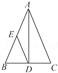Elucidate the elements visible in the diagram. The diagram depicts triangle ABC with vertices labeled as A, B, and C. From vertex A, an altitude (perpendicular segment) is drawn, intersecting side BC at point D. Additionally, point E is marked on the diagram, representing the midpoint of side AB, which also implies that segment AE is congruent to segment EB. This triangle may be used to demonstrate various geometric principles, such as the properties of similar triangles, the Pythagorean theorem, and the relationship between the sides and angles of a triangle. 